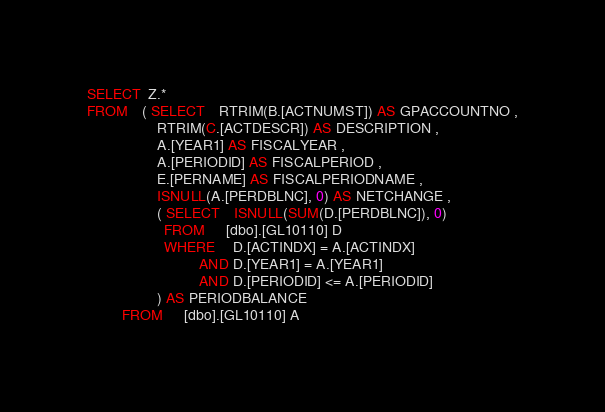<code> <loc_0><loc_0><loc_500><loc_500><_SQL_>SELECT  Z.*
FROM    ( SELECT    RTRIM(B.[ACTNUMST]) AS GPACCOUNTNO ,
                    RTRIM(C.[ACTDESCR]) AS DESCRIPTION ,
                    A.[YEAR1] AS FISCALYEAR ,
                    A.[PERIODID] AS FISCALPERIOD ,
                    E.[PERNAME] AS FISCALPERIODNAME ,
                    ISNULL(A.[PERDBLNC], 0) AS NETCHANGE ,
                    ( SELECT    ISNULL(SUM(D.[PERDBLNC]), 0)
                      FROM      [dbo].[GL10110] D
                      WHERE     D.[ACTINDX] = A.[ACTINDX]
                                AND D.[YEAR1] = A.[YEAR1]
                                AND D.[PERIODID] <= A.[PERIODID]
                    ) AS PERIODBALANCE
          FROM      [dbo].[GL10110] A</code> 